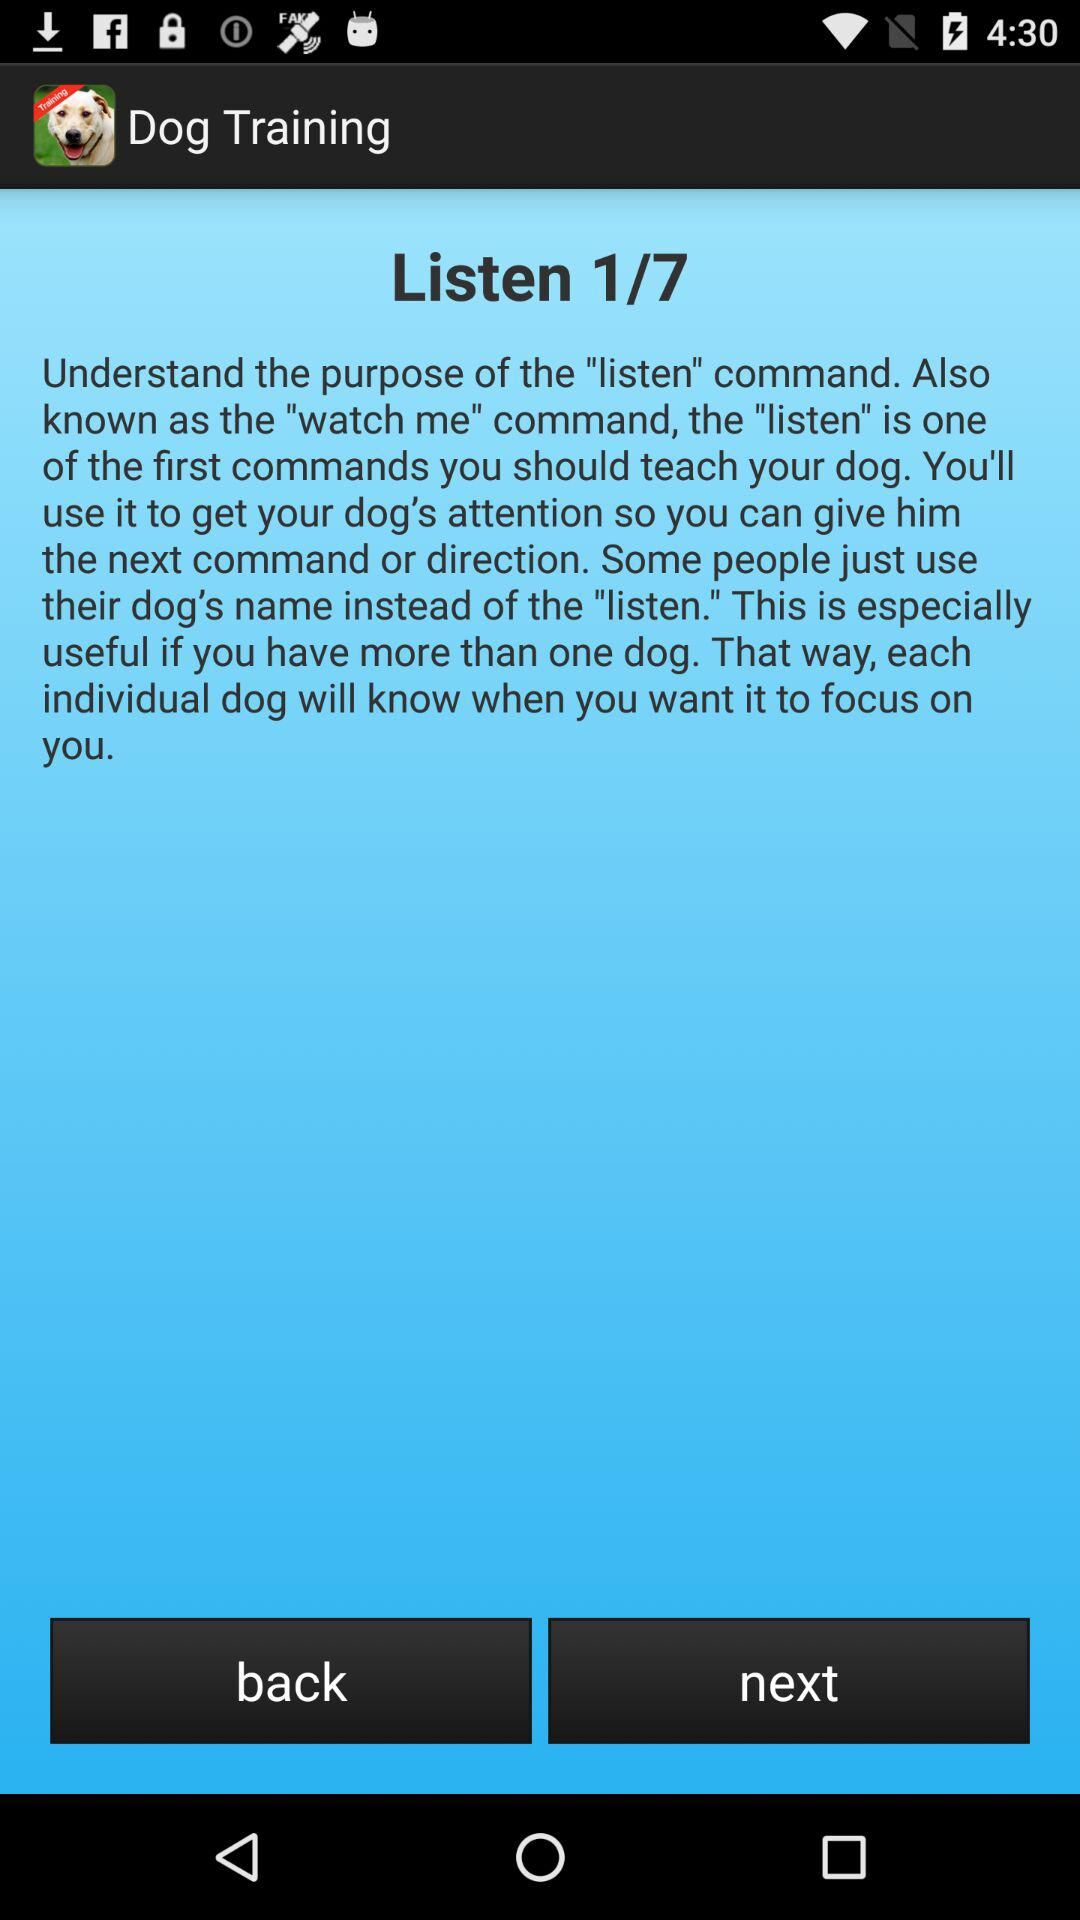Which command is the person on? The person is on the first command. 